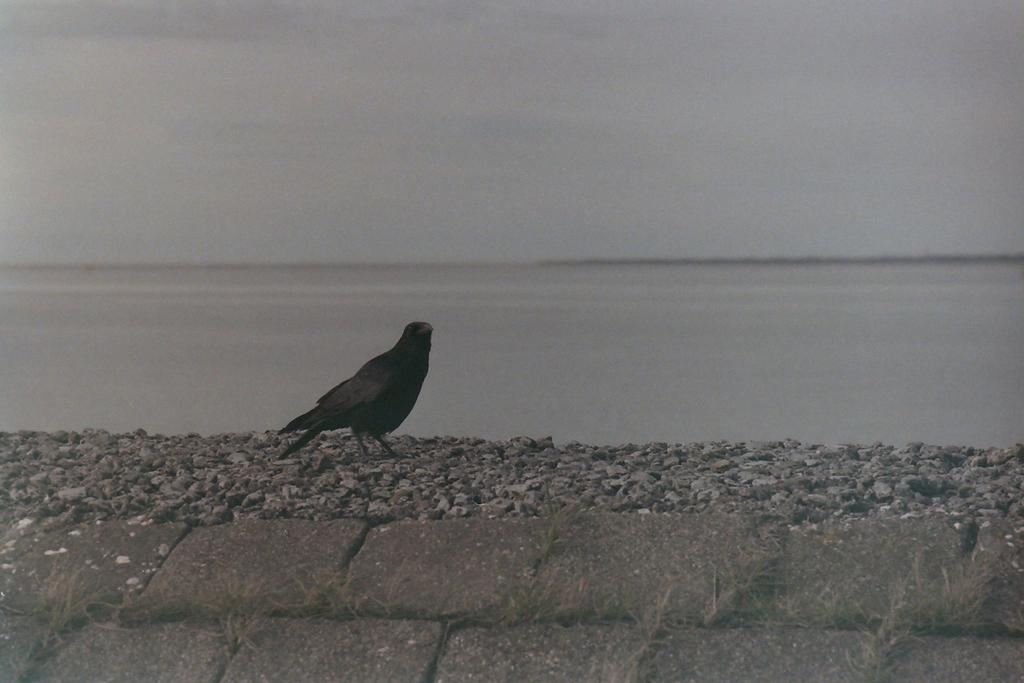What is the bird doing in the image? The bird is standing on stones in the image. What else can be seen in the image besides the bird? There is water visible in the image. What is visible at the top of the image? The sky is visible at the top of the image. What type of muscle is being exercised by the chairs in the image? There are no chairs present in the image, so the question about muscles cannot be answered. 